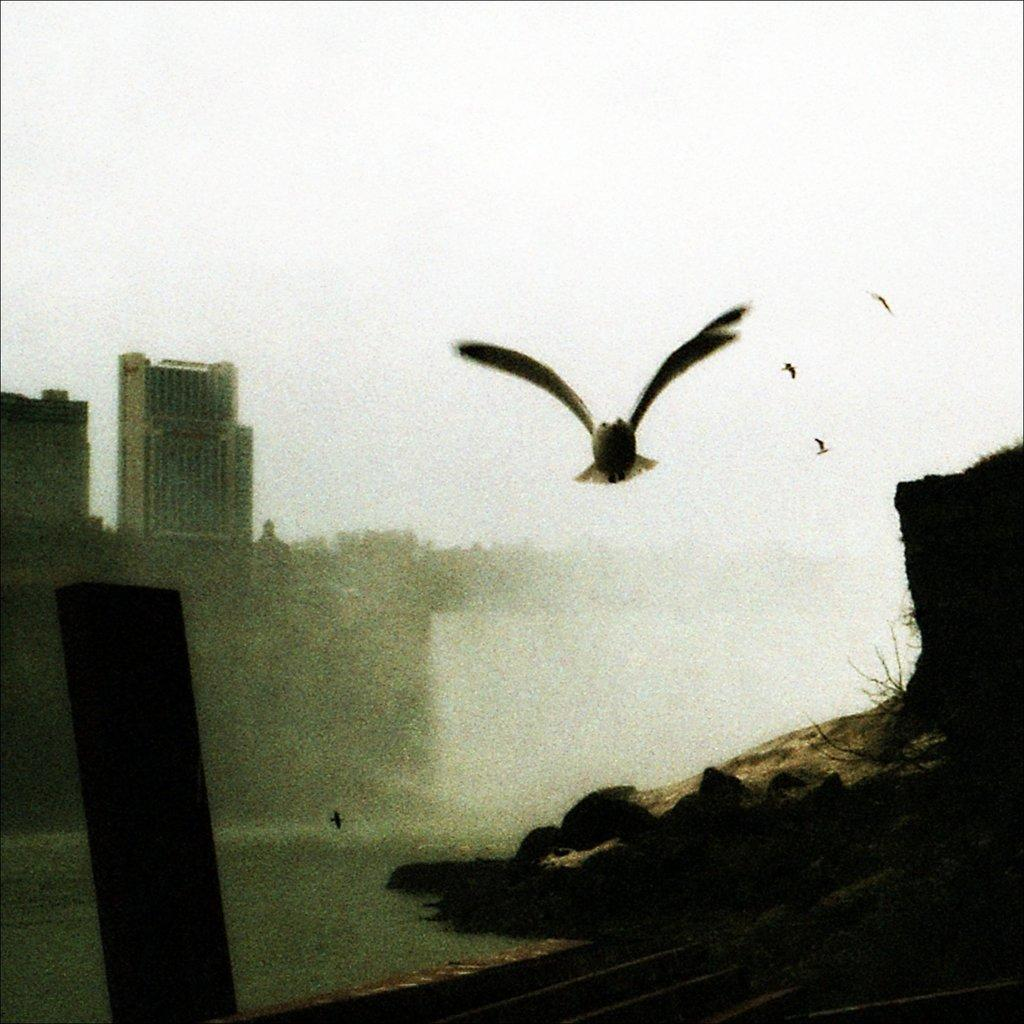What is happening in the image involving animals? There are birds flying in the image. What natural element is visible in the image? There is water visible in the image. What type of man-made structures can be seen in the image? There are buildings in the image. How would you describe the weather based on the image? The sky is cloudy in the image. Can you see any ants crawling on the buildings in the image? There are no ants visible in the image; it features birds flying, water, buildings, and a cloudy sky. What type of food is the bird holding in its mouth in the image? There is no bird holding any food in its mouth in the image; the birds are simply flying. 